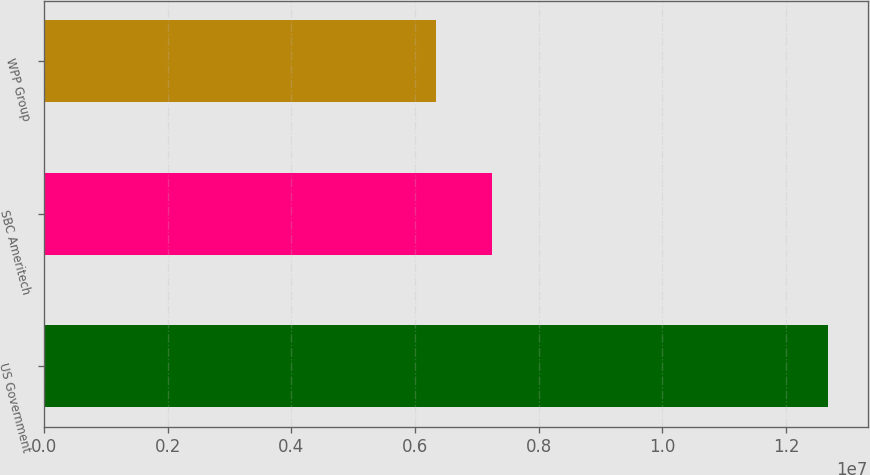Convert chart to OTSL. <chart><loc_0><loc_0><loc_500><loc_500><bar_chart><fcel>US Government<fcel>SBC Ameritech<fcel>WPP Group<nl><fcel>1.2685e+07<fcel>7.244e+06<fcel>6.345e+06<nl></chart> 